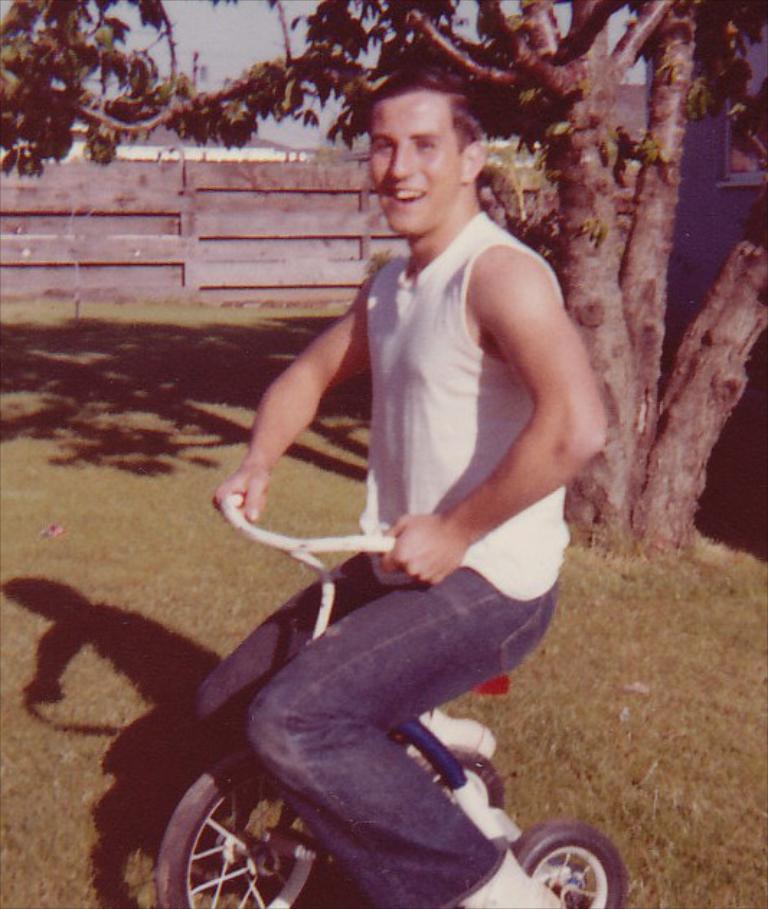Describe this image in one or two sentences. In the center of the image there is a person sitting on the bicycle. In the background we can see tree, grass, fencing, building and sky. 